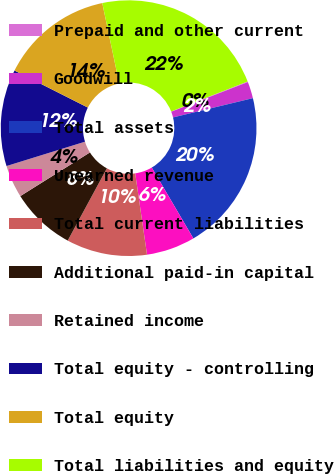Convert chart to OTSL. <chart><loc_0><loc_0><loc_500><loc_500><pie_chart><fcel>Prepaid and other current<fcel>Goodwill<fcel>Total assets<fcel>Unearned revenue<fcel>Total current liabilities<fcel>Additional paid-in capital<fcel>Retained income<fcel>Total equity - controlling<fcel>Total equity<fcel>Total liabilities and equity<nl><fcel>0.08%<fcel>2.1%<fcel>20.32%<fcel>6.15%<fcel>10.2%<fcel>8.18%<fcel>4.13%<fcel>12.23%<fcel>14.25%<fcel>22.35%<nl></chart> 